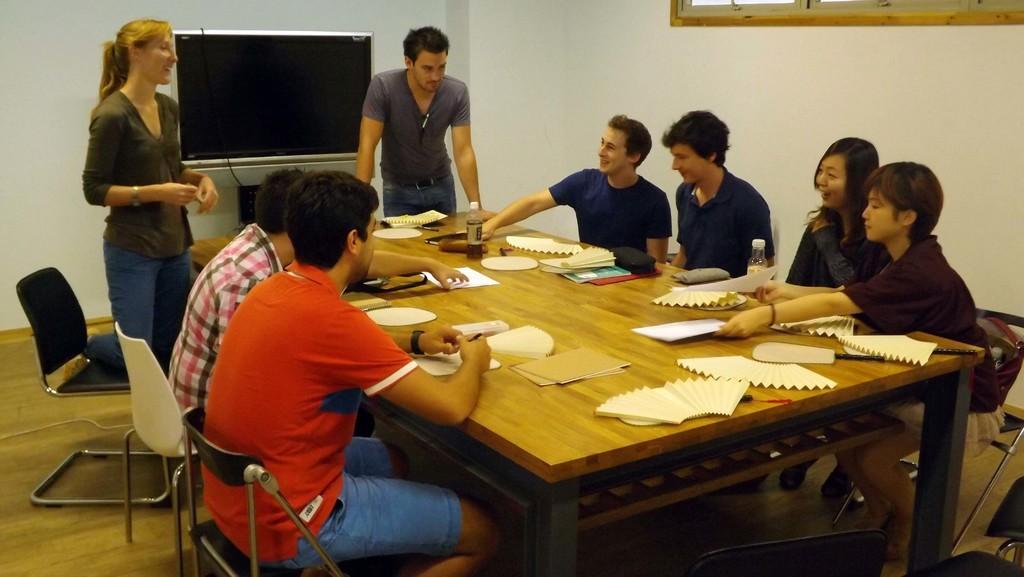Could you give a brief overview of what you see in this image? This picture shows there are two men sitting on the chair on the left and there are four people sitting on top right on the chair, there is a man and woman standing and smiling, there is a table in front of them with some papers and cardboard a bottle, notebooks and some stationery, there is also a smartphone and in the backdrop there is a television and on the right there is a wall and the window 